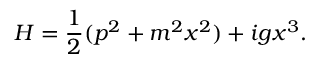<formula> <loc_0><loc_0><loc_500><loc_500>H = { \frac { 1 } { 2 } } ( p ^ { 2 } + m ^ { 2 } x ^ { 2 } ) + i g x ^ { 3 } .</formula> 